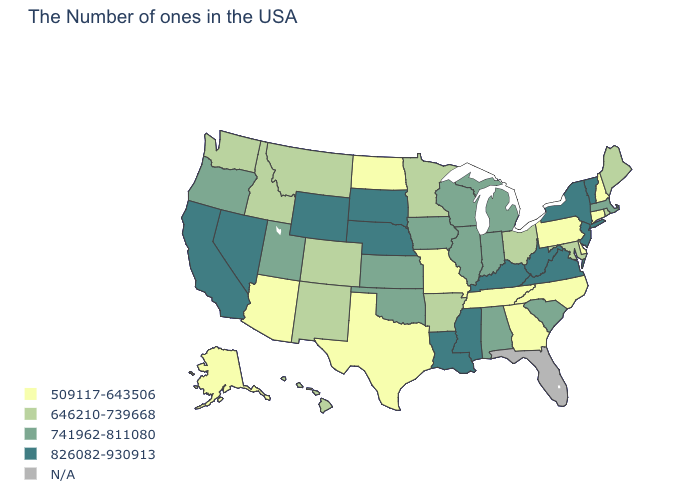What is the value of Indiana?
Concise answer only. 741962-811080. Which states have the highest value in the USA?
Keep it brief. Vermont, New York, New Jersey, Virginia, West Virginia, Kentucky, Mississippi, Louisiana, Nebraska, South Dakota, Wyoming, Nevada, California. Does the map have missing data?
Be succinct. Yes. What is the value of Hawaii?
Concise answer only. 646210-739668. Which states have the highest value in the USA?
Keep it brief. Vermont, New York, New Jersey, Virginia, West Virginia, Kentucky, Mississippi, Louisiana, Nebraska, South Dakota, Wyoming, Nevada, California. Name the states that have a value in the range 646210-739668?
Concise answer only. Maine, Rhode Island, Maryland, Ohio, Arkansas, Minnesota, Colorado, New Mexico, Montana, Idaho, Washington, Hawaii. What is the value of Utah?
Answer briefly. 741962-811080. Does Oregon have the highest value in the USA?
Be succinct. No. Among the states that border Washington , does Oregon have the lowest value?
Answer briefly. No. Name the states that have a value in the range N/A?
Answer briefly. Florida. Among the states that border Illinois , which have the lowest value?
Quick response, please. Missouri. Name the states that have a value in the range 646210-739668?
Quick response, please. Maine, Rhode Island, Maryland, Ohio, Arkansas, Minnesota, Colorado, New Mexico, Montana, Idaho, Washington, Hawaii. What is the value of Mississippi?
Write a very short answer. 826082-930913. Name the states that have a value in the range 646210-739668?
Write a very short answer. Maine, Rhode Island, Maryland, Ohio, Arkansas, Minnesota, Colorado, New Mexico, Montana, Idaho, Washington, Hawaii. 